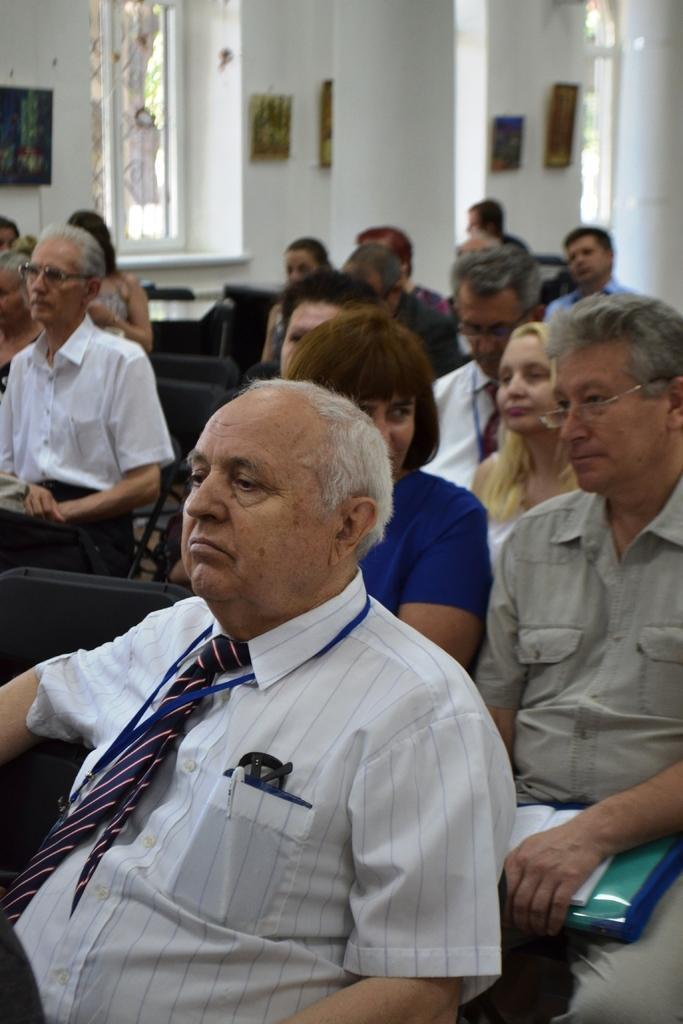Describe this image in one or two sentences. In the image there are many old men sitting on chairs, this seems to be clicked inside a church, in the back there is a window on the wall with photo frames on either side of it. 